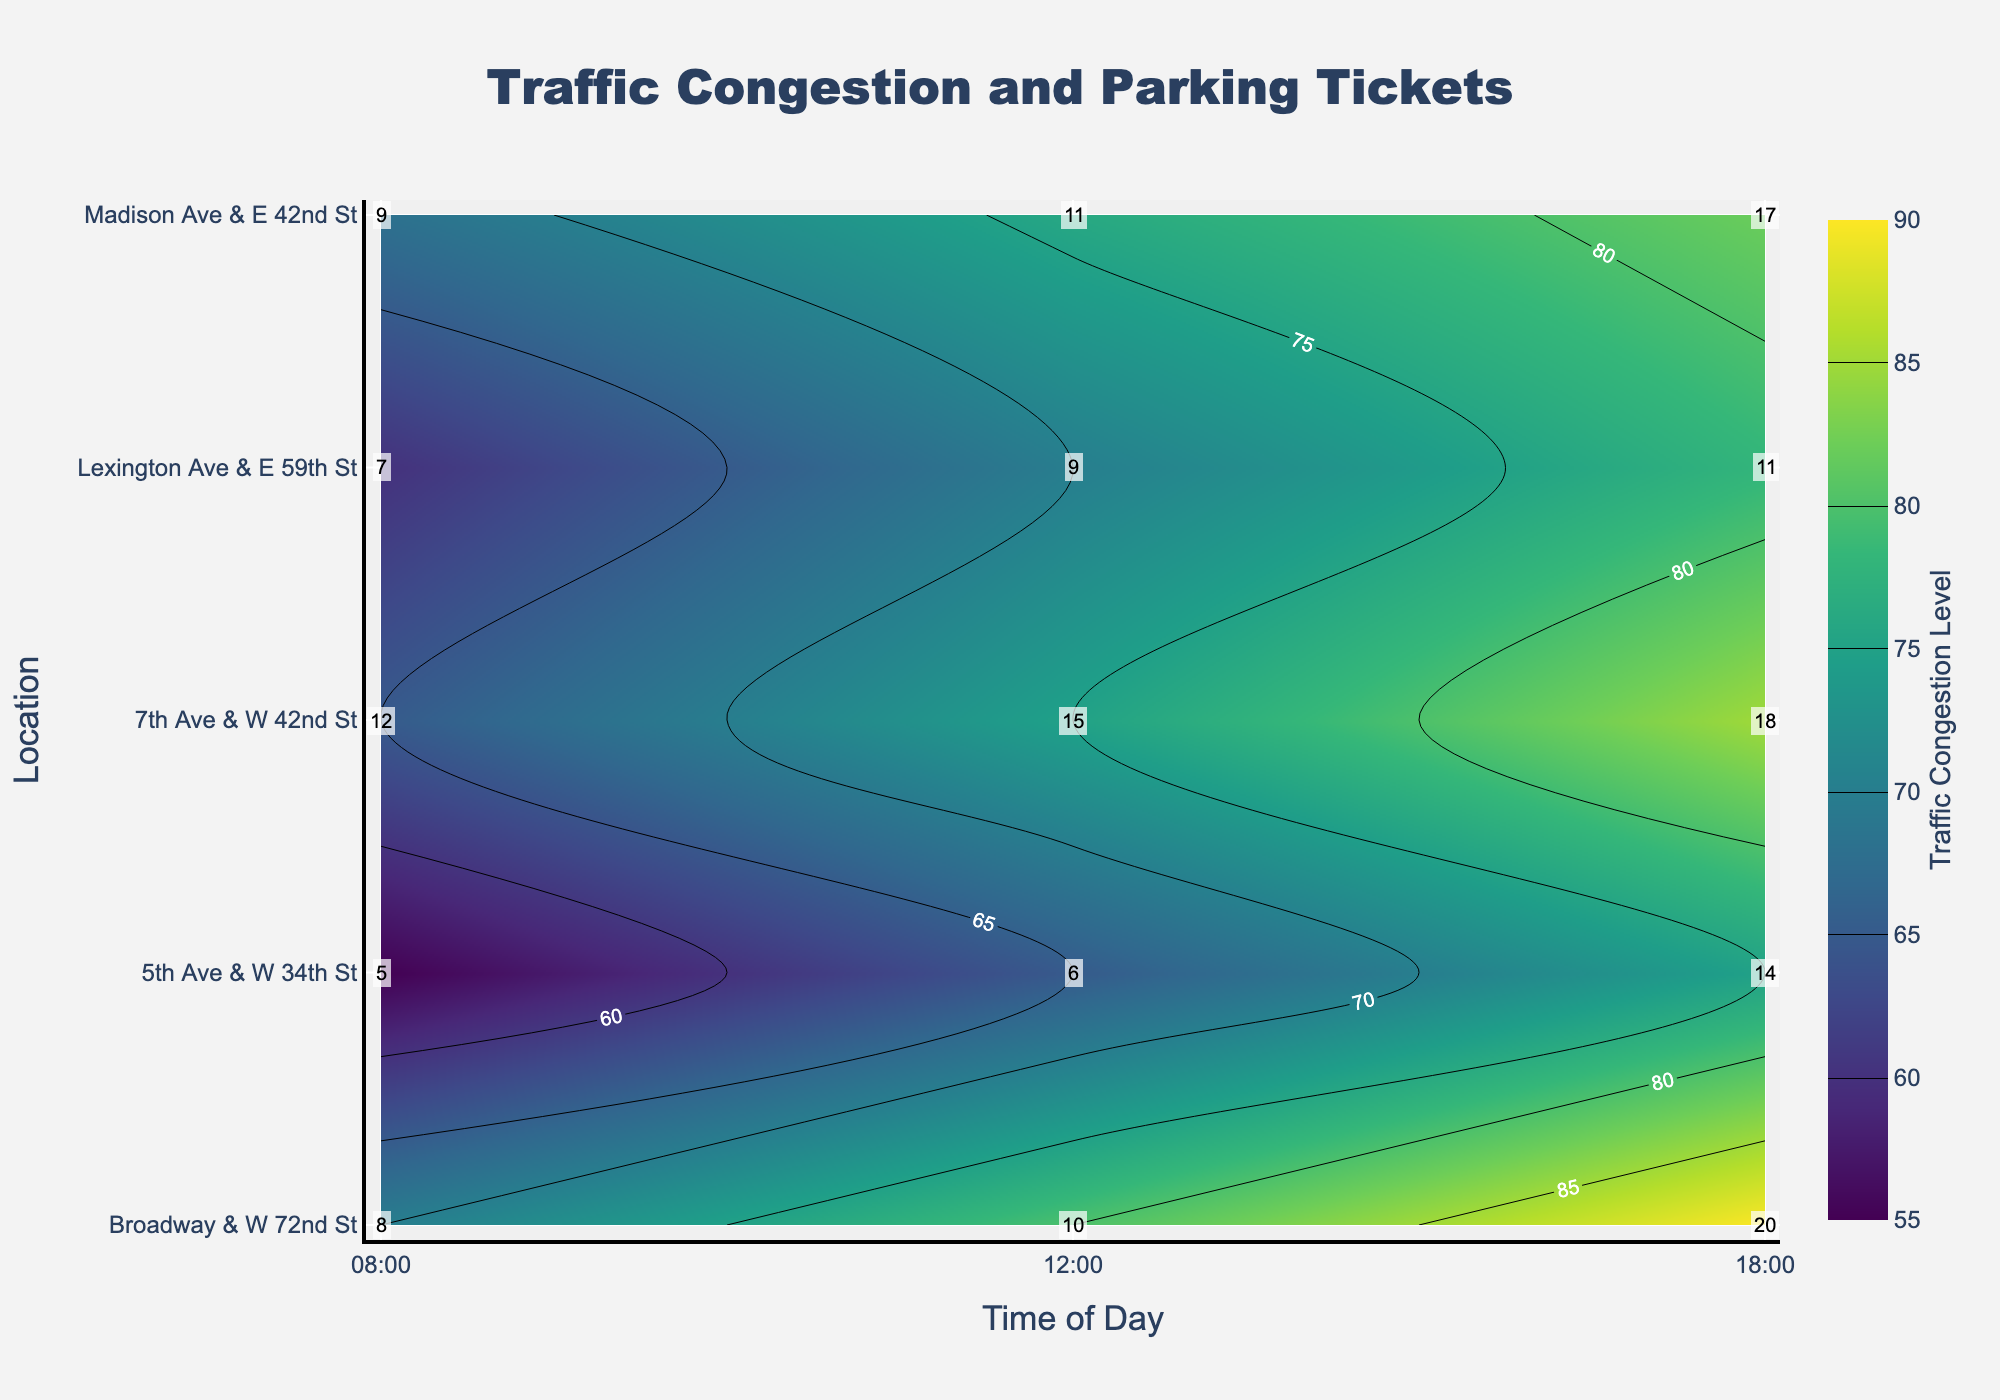What's the title of the figure? The title of the figure is located at the top and centers the description of the data represented in the contour plot. It can be read directly from the figure.
Answer: Traffic Congestion and Parking Tickets Which location has the highest traffic congestion level at 18:00? By looking at the y-axis (representing locations) and the x-axis (representing times), we can locate the intersection at 18:00 for each location and identify the one with the highest congestion level through the color gradient and contours.
Answer: 5th Ave & W 34th St What is the number of parking tickets at Broadway & W 72nd St at 12:00? The number of parking tickets is annotated on the figure at the intersection of each location and time. By finding the point at Broadway & W 72nd St at 12:00, we can read the value directly.
Answer: 15 Which time of day is associated with the highest average traffic congestion level across all locations? To answer this, calculate the average congestion level across all locations for each time and compare these averages. The time with the highest average is the answer. For 08:00: (65+70+55+60+68)/5 = 63.6, for 12:00: (75+80+65+70+76)/5 = 73.2, and for 18:00: (85+90+75+78+82)/5 = 82
Answer: 18:00 What trend can be observed between traffic congestion levels and the number of parking tickets? By closely examining the contour levels and the annotated parking tickets, we can observe how changes in congestion levels align with changes in the number of tickets. Typically, as congestion levels increase, the number of parking tickets also tends to increase.
Answer: Positive correlation Which location has the lowest number of parking tickets at 08:00 and what is the congestion level there? First, examine the annotations at 08:00 across all locations to determine which has the lowest number of parking tickets. Then, check the corresponding congestion level at that same point.
Answer: 7th Ave & W 42nd St, 55 How does the traffic congestion level change at 5th Ave & W 34th St over the day? By tracing the traffic congestion levels at 5th Ave & W 34th St at different times (08:00, 12:00, 18:00) and noting the changes in values, we notice the increase from 70 to 80 to 90.
Answer: It increases At what time and location is the number of parking tickets the highest? By scanning the annotations for the highest value across all times and locations, we identify the point where the number of tickets is the greatest.
Answer: 5th Ave & W 34th St at 18:00, 20 Compare the traffic congestion levels at 12:00 for Broadway & W 72nd St and Lexington Ave & E 59th St. Which is higher? Locate both data points at 12:00 on the y-axis and compare the associated traffic congestion levels. Broadway & W 72nd St has a congestion level of 75, while Lexington Ave & E 59th St has 70.
Answer: Broadway & W 72nd St What's the difference in the number of parking tickets between Madison Ave & E 42nd St and Lexington Ave & E 59th St at 12:00? By identifying the number of parking tickets at 12:00 for both locations and subtracting the values, Madison Ave & E 42nd St has 11 and Lexington Ave & E 59th St has 9. Thus, the difference is 11 - 9 = 2.
Answer: 2 